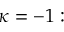<formula> <loc_0><loc_0><loc_500><loc_500>\kappa = - 1 \colon</formula> 